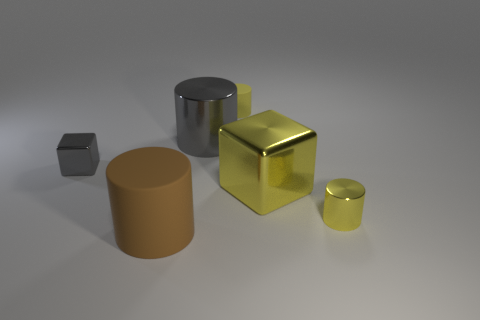Subtract all big metal cylinders. How many cylinders are left? 3 Subtract all brown cubes. How many yellow cylinders are left? 2 Add 4 matte cylinders. How many objects exist? 10 Subtract 1 blocks. How many blocks are left? 1 Subtract all gray blocks. How many blocks are left? 1 Subtract all big brown things. Subtract all gray metallic objects. How many objects are left? 3 Add 5 tiny gray metal things. How many tiny gray metal things are left? 6 Add 6 tiny yellow rubber things. How many tiny yellow rubber things exist? 7 Subtract 0 purple spheres. How many objects are left? 6 Subtract all cylinders. How many objects are left? 2 